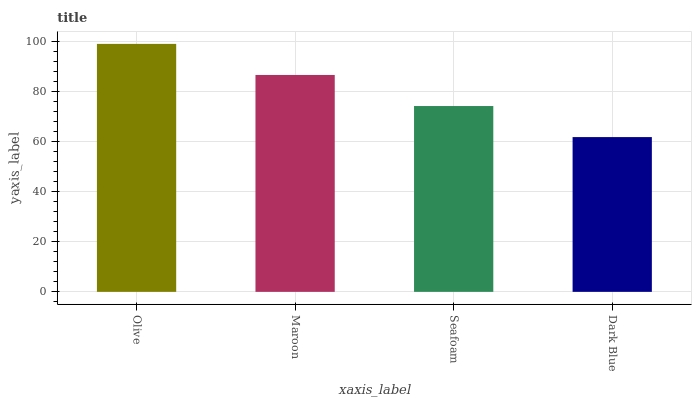Is Dark Blue the minimum?
Answer yes or no. Yes. Is Olive the maximum?
Answer yes or no. Yes. Is Maroon the minimum?
Answer yes or no. No. Is Maroon the maximum?
Answer yes or no. No. Is Olive greater than Maroon?
Answer yes or no. Yes. Is Maroon less than Olive?
Answer yes or no. Yes. Is Maroon greater than Olive?
Answer yes or no. No. Is Olive less than Maroon?
Answer yes or no. No. Is Maroon the high median?
Answer yes or no. Yes. Is Seafoam the low median?
Answer yes or no. Yes. Is Olive the high median?
Answer yes or no. No. Is Maroon the low median?
Answer yes or no. No. 